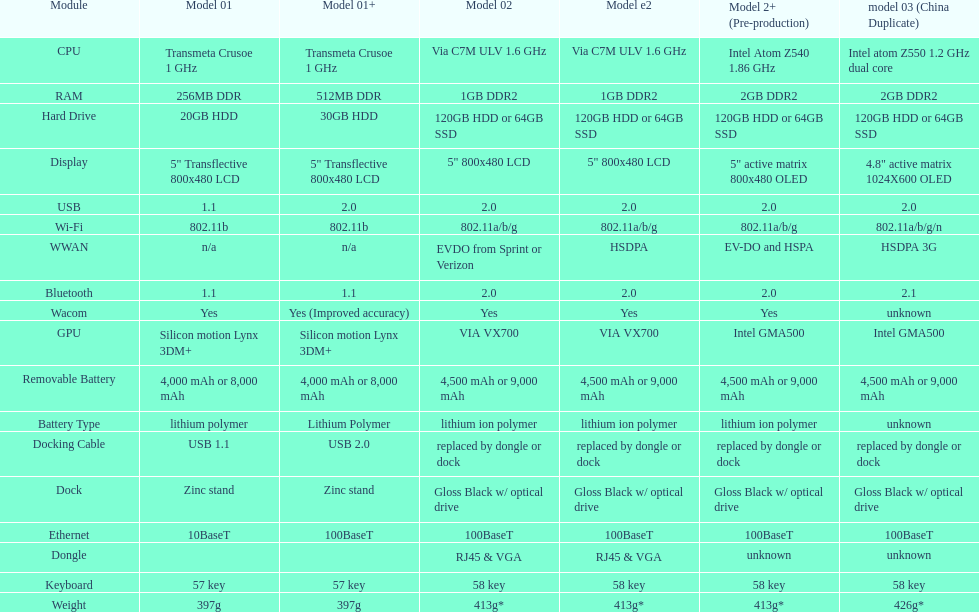Which model weighs the most, according to the table? Model 03 (china copy). 